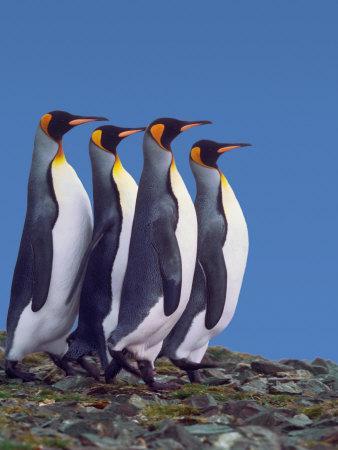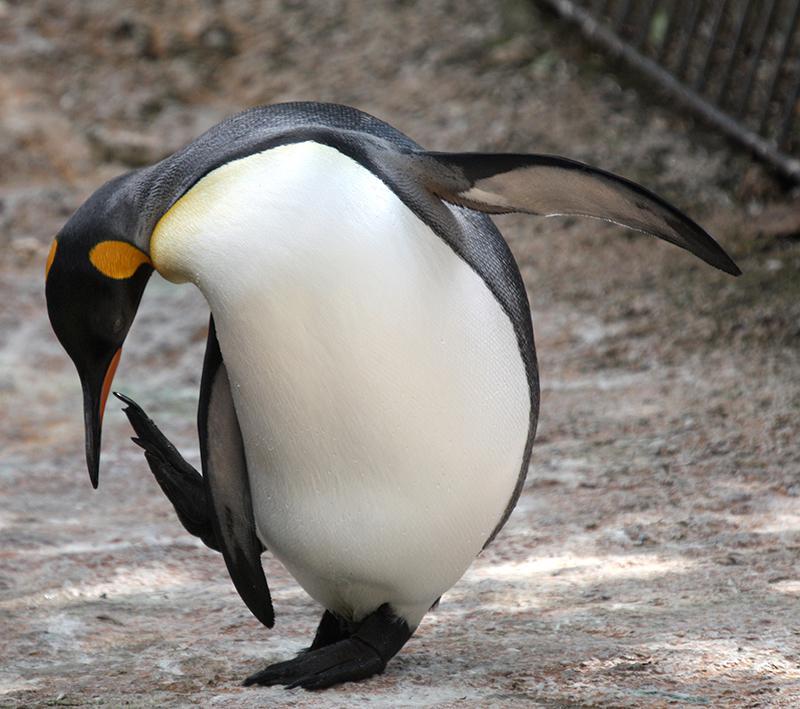The first image is the image on the left, the second image is the image on the right. Given the left and right images, does the statement "the penguin in the image on the right is looking down" hold true? Answer yes or no. Yes. The first image is the image on the left, the second image is the image on the right. Evaluate the accuracy of this statement regarding the images: "In one image, exactly four penguins are standing together.". Is it true? Answer yes or no. Yes. 